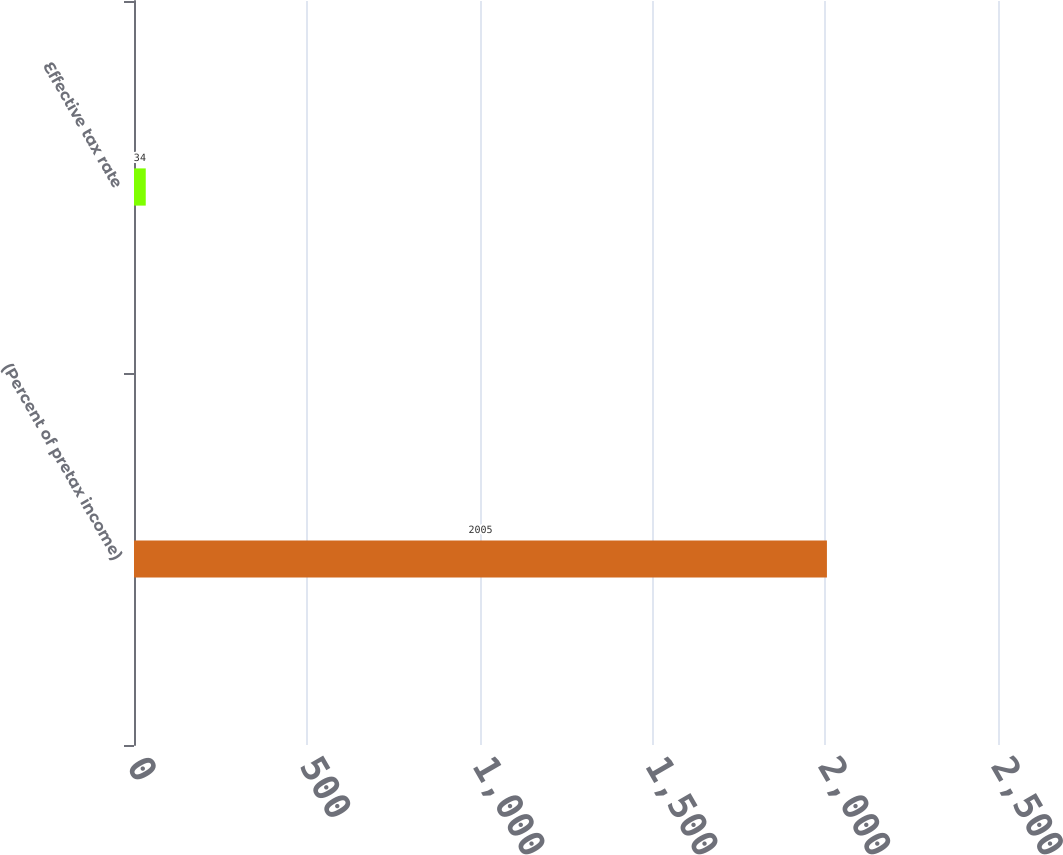Convert chart. <chart><loc_0><loc_0><loc_500><loc_500><bar_chart><fcel>(Percent of pretax income)<fcel>Effective tax rate<nl><fcel>2005<fcel>34<nl></chart> 